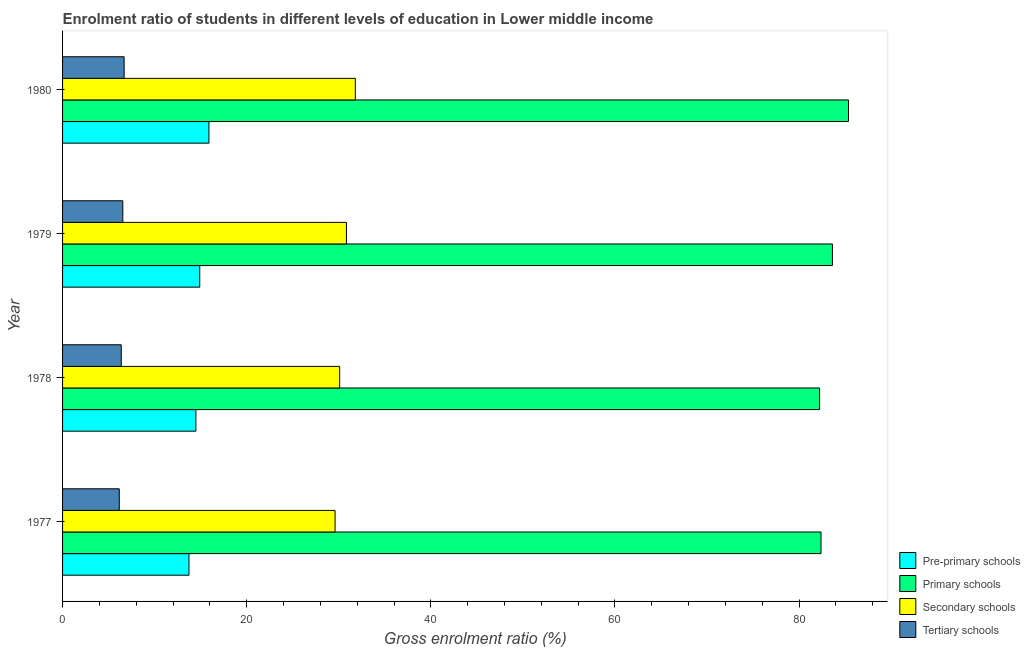How many different coloured bars are there?
Provide a short and direct response. 4. How many groups of bars are there?
Your answer should be compact. 4. Are the number of bars per tick equal to the number of legend labels?
Your answer should be compact. Yes. How many bars are there on the 4th tick from the top?
Provide a short and direct response. 4. How many bars are there on the 1st tick from the bottom?
Offer a terse response. 4. In how many cases, is the number of bars for a given year not equal to the number of legend labels?
Offer a terse response. 0. What is the gross enrolment ratio in primary schools in 1977?
Give a very brief answer. 82.38. Across all years, what is the maximum gross enrolment ratio in primary schools?
Give a very brief answer. 85.36. Across all years, what is the minimum gross enrolment ratio in secondary schools?
Offer a terse response. 29.6. In which year was the gross enrolment ratio in primary schools minimum?
Make the answer very short. 1978. What is the total gross enrolment ratio in pre-primary schools in the graph?
Your answer should be very brief. 59.01. What is the difference between the gross enrolment ratio in secondary schools in 1979 and that in 1980?
Offer a very short reply. -0.96. What is the difference between the gross enrolment ratio in secondary schools in 1977 and the gross enrolment ratio in pre-primary schools in 1978?
Offer a very short reply. 15.11. What is the average gross enrolment ratio in tertiary schools per year?
Keep it short and to the point. 6.44. In the year 1977, what is the difference between the gross enrolment ratio in pre-primary schools and gross enrolment ratio in primary schools?
Ensure brevity in your answer.  -68.65. In how many years, is the gross enrolment ratio in tertiary schools greater than 44 %?
Ensure brevity in your answer.  0. What is the ratio of the gross enrolment ratio in tertiary schools in 1977 to that in 1980?
Your answer should be very brief. 0.92. What is the difference between the highest and the second highest gross enrolment ratio in pre-primary schools?
Give a very brief answer. 1. What is the difference between the highest and the lowest gross enrolment ratio in secondary schools?
Provide a short and direct response. 2.2. In how many years, is the gross enrolment ratio in primary schools greater than the average gross enrolment ratio in primary schools taken over all years?
Offer a very short reply. 2. Is the sum of the gross enrolment ratio in secondary schools in 1979 and 1980 greater than the maximum gross enrolment ratio in primary schools across all years?
Give a very brief answer. No. What does the 3rd bar from the top in 1978 represents?
Your response must be concise. Primary schools. What does the 2nd bar from the bottom in 1978 represents?
Give a very brief answer. Primary schools. Is it the case that in every year, the sum of the gross enrolment ratio in pre-primary schools and gross enrolment ratio in primary schools is greater than the gross enrolment ratio in secondary schools?
Keep it short and to the point. Yes. Does the graph contain any zero values?
Your response must be concise. No. Where does the legend appear in the graph?
Make the answer very short. Bottom right. What is the title of the graph?
Your answer should be compact. Enrolment ratio of students in different levels of education in Lower middle income. What is the Gross enrolment ratio (%) of Pre-primary schools in 1977?
Make the answer very short. 13.73. What is the Gross enrolment ratio (%) in Primary schools in 1977?
Provide a short and direct response. 82.38. What is the Gross enrolment ratio (%) in Secondary schools in 1977?
Provide a short and direct response. 29.6. What is the Gross enrolment ratio (%) of Tertiary schools in 1977?
Ensure brevity in your answer.  6.16. What is the Gross enrolment ratio (%) of Pre-primary schools in 1978?
Keep it short and to the point. 14.48. What is the Gross enrolment ratio (%) in Primary schools in 1978?
Offer a terse response. 82.22. What is the Gross enrolment ratio (%) of Secondary schools in 1978?
Ensure brevity in your answer.  30.1. What is the Gross enrolment ratio (%) of Tertiary schools in 1978?
Provide a short and direct response. 6.37. What is the Gross enrolment ratio (%) of Pre-primary schools in 1979?
Your answer should be very brief. 14.9. What is the Gross enrolment ratio (%) in Primary schools in 1979?
Ensure brevity in your answer.  83.62. What is the Gross enrolment ratio (%) of Secondary schools in 1979?
Your answer should be very brief. 30.83. What is the Gross enrolment ratio (%) of Tertiary schools in 1979?
Keep it short and to the point. 6.54. What is the Gross enrolment ratio (%) of Pre-primary schools in 1980?
Provide a short and direct response. 15.9. What is the Gross enrolment ratio (%) of Primary schools in 1980?
Your answer should be compact. 85.36. What is the Gross enrolment ratio (%) of Secondary schools in 1980?
Keep it short and to the point. 31.8. What is the Gross enrolment ratio (%) of Tertiary schools in 1980?
Offer a terse response. 6.69. Across all years, what is the maximum Gross enrolment ratio (%) in Pre-primary schools?
Give a very brief answer. 15.9. Across all years, what is the maximum Gross enrolment ratio (%) of Primary schools?
Ensure brevity in your answer.  85.36. Across all years, what is the maximum Gross enrolment ratio (%) of Secondary schools?
Offer a very short reply. 31.8. Across all years, what is the maximum Gross enrolment ratio (%) in Tertiary schools?
Offer a terse response. 6.69. Across all years, what is the minimum Gross enrolment ratio (%) of Pre-primary schools?
Make the answer very short. 13.73. Across all years, what is the minimum Gross enrolment ratio (%) in Primary schools?
Give a very brief answer. 82.22. Across all years, what is the minimum Gross enrolment ratio (%) in Secondary schools?
Provide a short and direct response. 29.6. Across all years, what is the minimum Gross enrolment ratio (%) in Tertiary schools?
Offer a very short reply. 6.16. What is the total Gross enrolment ratio (%) of Pre-primary schools in the graph?
Provide a succinct answer. 59.01. What is the total Gross enrolment ratio (%) in Primary schools in the graph?
Ensure brevity in your answer.  333.58. What is the total Gross enrolment ratio (%) of Secondary schools in the graph?
Give a very brief answer. 122.33. What is the total Gross enrolment ratio (%) in Tertiary schools in the graph?
Provide a short and direct response. 25.76. What is the difference between the Gross enrolment ratio (%) of Pre-primary schools in 1977 and that in 1978?
Provide a short and direct response. -0.75. What is the difference between the Gross enrolment ratio (%) in Primary schools in 1977 and that in 1978?
Provide a succinct answer. 0.15. What is the difference between the Gross enrolment ratio (%) in Secondary schools in 1977 and that in 1978?
Provide a succinct answer. -0.5. What is the difference between the Gross enrolment ratio (%) of Tertiary schools in 1977 and that in 1978?
Offer a very short reply. -0.21. What is the difference between the Gross enrolment ratio (%) of Pre-primary schools in 1977 and that in 1979?
Make the answer very short. -1.17. What is the difference between the Gross enrolment ratio (%) in Primary schools in 1977 and that in 1979?
Offer a very short reply. -1.24. What is the difference between the Gross enrolment ratio (%) of Secondary schools in 1977 and that in 1979?
Provide a short and direct response. -1.24. What is the difference between the Gross enrolment ratio (%) of Tertiary schools in 1977 and that in 1979?
Offer a very short reply. -0.38. What is the difference between the Gross enrolment ratio (%) in Pre-primary schools in 1977 and that in 1980?
Keep it short and to the point. -2.17. What is the difference between the Gross enrolment ratio (%) of Primary schools in 1977 and that in 1980?
Keep it short and to the point. -2.99. What is the difference between the Gross enrolment ratio (%) in Secondary schools in 1977 and that in 1980?
Give a very brief answer. -2.2. What is the difference between the Gross enrolment ratio (%) in Tertiary schools in 1977 and that in 1980?
Ensure brevity in your answer.  -0.53. What is the difference between the Gross enrolment ratio (%) of Pre-primary schools in 1978 and that in 1979?
Give a very brief answer. -0.42. What is the difference between the Gross enrolment ratio (%) of Primary schools in 1978 and that in 1979?
Give a very brief answer. -1.39. What is the difference between the Gross enrolment ratio (%) of Secondary schools in 1978 and that in 1979?
Provide a succinct answer. -0.73. What is the difference between the Gross enrolment ratio (%) of Tertiary schools in 1978 and that in 1979?
Provide a succinct answer. -0.17. What is the difference between the Gross enrolment ratio (%) in Pre-primary schools in 1978 and that in 1980?
Ensure brevity in your answer.  -1.42. What is the difference between the Gross enrolment ratio (%) in Primary schools in 1978 and that in 1980?
Offer a very short reply. -3.14. What is the difference between the Gross enrolment ratio (%) in Secondary schools in 1978 and that in 1980?
Offer a very short reply. -1.7. What is the difference between the Gross enrolment ratio (%) in Tertiary schools in 1978 and that in 1980?
Your response must be concise. -0.31. What is the difference between the Gross enrolment ratio (%) of Pre-primary schools in 1979 and that in 1980?
Your answer should be compact. -1. What is the difference between the Gross enrolment ratio (%) of Primary schools in 1979 and that in 1980?
Provide a short and direct response. -1.75. What is the difference between the Gross enrolment ratio (%) in Secondary schools in 1979 and that in 1980?
Make the answer very short. -0.96. What is the difference between the Gross enrolment ratio (%) of Tertiary schools in 1979 and that in 1980?
Offer a very short reply. -0.14. What is the difference between the Gross enrolment ratio (%) of Pre-primary schools in 1977 and the Gross enrolment ratio (%) of Primary schools in 1978?
Your answer should be compact. -68.49. What is the difference between the Gross enrolment ratio (%) in Pre-primary schools in 1977 and the Gross enrolment ratio (%) in Secondary schools in 1978?
Make the answer very short. -16.37. What is the difference between the Gross enrolment ratio (%) of Pre-primary schools in 1977 and the Gross enrolment ratio (%) of Tertiary schools in 1978?
Make the answer very short. 7.35. What is the difference between the Gross enrolment ratio (%) of Primary schools in 1977 and the Gross enrolment ratio (%) of Secondary schools in 1978?
Make the answer very short. 52.28. What is the difference between the Gross enrolment ratio (%) in Primary schools in 1977 and the Gross enrolment ratio (%) in Tertiary schools in 1978?
Your response must be concise. 76. What is the difference between the Gross enrolment ratio (%) in Secondary schools in 1977 and the Gross enrolment ratio (%) in Tertiary schools in 1978?
Your answer should be very brief. 23.22. What is the difference between the Gross enrolment ratio (%) in Pre-primary schools in 1977 and the Gross enrolment ratio (%) in Primary schools in 1979?
Your response must be concise. -69.89. What is the difference between the Gross enrolment ratio (%) of Pre-primary schools in 1977 and the Gross enrolment ratio (%) of Secondary schools in 1979?
Provide a succinct answer. -17.1. What is the difference between the Gross enrolment ratio (%) in Pre-primary schools in 1977 and the Gross enrolment ratio (%) in Tertiary schools in 1979?
Offer a terse response. 7.19. What is the difference between the Gross enrolment ratio (%) in Primary schools in 1977 and the Gross enrolment ratio (%) in Secondary schools in 1979?
Offer a terse response. 51.54. What is the difference between the Gross enrolment ratio (%) of Primary schools in 1977 and the Gross enrolment ratio (%) of Tertiary schools in 1979?
Your answer should be compact. 75.83. What is the difference between the Gross enrolment ratio (%) in Secondary schools in 1977 and the Gross enrolment ratio (%) in Tertiary schools in 1979?
Offer a terse response. 23.05. What is the difference between the Gross enrolment ratio (%) in Pre-primary schools in 1977 and the Gross enrolment ratio (%) in Primary schools in 1980?
Provide a short and direct response. -71.64. What is the difference between the Gross enrolment ratio (%) of Pre-primary schools in 1977 and the Gross enrolment ratio (%) of Secondary schools in 1980?
Keep it short and to the point. -18.07. What is the difference between the Gross enrolment ratio (%) of Pre-primary schools in 1977 and the Gross enrolment ratio (%) of Tertiary schools in 1980?
Offer a very short reply. 7.04. What is the difference between the Gross enrolment ratio (%) in Primary schools in 1977 and the Gross enrolment ratio (%) in Secondary schools in 1980?
Your response must be concise. 50.58. What is the difference between the Gross enrolment ratio (%) of Primary schools in 1977 and the Gross enrolment ratio (%) of Tertiary schools in 1980?
Your answer should be very brief. 75.69. What is the difference between the Gross enrolment ratio (%) of Secondary schools in 1977 and the Gross enrolment ratio (%) of Tertiary schools in 1980?
Give a very brief answer. 22.91. What is the difference between the Gross enrolment ratio (%) of Pre-primary schools in 1978 and the Gross enrolment ratio (%) of Primary schools in 1979?
Your response must be concise. -69.13. What is the difference between the Gross enrolment ratio (%) of Pre-primary schools in 1978 and the Gross enrolment ratio (%) of Secondary schools in 1979?
Offer a very short reply. -16.35. What is the difference between the Gross enrolment ratio (%) of Pre-primary schools in 1978 and the Gross enrolment ratio (%) of Tertiary schools in 1979?
Offer a very short reply. 7.94. What is the difference between the Gross enrolment ratio (%) in Primary schools in 1978 and the Gross enrolment ratio (%) in Secondary schools in 1979?
Provide a succinct answer. 51.39. What is the difference between the Gross enrolment ratio (%) of Primary schools in 1978 and the Gross enrolment ratio (%) of Tertiary schools in 1979?
Make the answer very short. 75.68. What is the difference between the Gross enrolment ratio (%) of Secondary schools in 1978 and the Gross enrolment ratio (%) of Tertiary schools in 1979?
Keep it short and to the point. 23.56. What is the difference between the Gross enrolment ratio (%) of Pre-primary schools in 1978 and the Gross enrolment ratio (%) of Primary schools in 1980?
Offer a very short reply. -70.88. What is the difference between the Gross enrolment ratio (%) of Pre-primary schools in 1978 and the Gross enrolment ratio (%) of Secondary schools in 1980?
Your answer should be compact. -17.32. What is the difference between the Gross enrolment ratio (%) in Pre-primary schools in 1978 and the Gross enrolment ratio (%) in Tertiary schools in 1980?
Your response must be concise. 7.79. What is the difference between the Gross enrolment ratio (%) of Primary schools in 1978 and the Gross enrolment ratio (%) of Secondary schools in 1980?
Give a very brief answer. 50.43. What is the difference between the Gross enrolment ratio (%) in Primary schools in 1978 and the Gross enrolment ratio (%) in Tertiary schools in 1980?
Keep it short and to the point. 75.54. What is the difference between the Gross enrolment ratio (%) of Secondary schools in 1978 and the Gross enrolment ratio (%) of Tertiary schools in 1980?
Your answer should be compact. 23.41. What is the difference between the Gross enrolment ratio (%) of Pre-primary schools in 1979 and the Gross enrolment ratio (%) of Primary schools in 1980?
Your response must be concise. -70.46. What is the difference between the Gross enrolment ratio (%) in Pre-primary schools in 1979 and the Gross enrolment ratio (%) in Secondary schools in 1980?
Offer a terse response. -16.9. What is the difference between the Gross enrolment ratio (%) of Pre-primary schools in 1979 and the Gross enrolment ratio (%) of Tertiary schools in 1980?
Provide a succinct answer. 8.21. What is the difference between the Gross enrolment ratio (%) in Primary schools in 1979 and the Gross enrolment ratio (%) in Secondary schools in 1980?
Your response must be concise. 51.82. What is the difference between the Gross enrolment ratio (%) in Primary schools in 1979 and the Gross enrolment ratio (%) in Tertiary schools in 1980?
Provide a short and direct response. 76.93. What is the difference between the Gross enrolment ratio (%) in Secondary schools in 1979 and the Gross enrolment ratio (%) in Tertiary schools in 1980?
Give a very brief answer. 24.15. What is the average Gross enrolment ratio (%) in Pre-primary schools per year?
Your answer should be compact. 14.75. What is the average Gross enrolment ratio (%) in Primary schools per year?
Offer a terse response. 83.39. What is the average Gross enrolment ratio (%) in Secondary schools per year?
Give a very brief answer. 30.58. What is the average Gross enrolment ratio (%) in Tertiary schools per year?
Offer a very short reply. 6.44. In the year 1977, what is the difference between the Gross enrolment ratio (%) of Pre-primary schools and Gross enrolment ratio (%) of Primary schools?
Your response must be concise. -68.65. In the year 1977, what is the difference between the Gross enrolment ratio (%) in Pre-primary schools and Gross enrolment ratio (%) in Secondary schools?
Provide a succinct answer. -15.87. In the year 1977, what is the difference between the Gross enrolment ratio (%) of Pre-primary schools and Gross enrolment ratio (%) of Tertiary schools?
Offer a very short reply. 7.57. In the year 1977, what is the difference between the Gross enrolment ratio (%) in Primary schools and Gross enrolment ratio (%) in Secondary schools?
Ensure brevity in your answer.  52.78. In the year 1977, what is the difference between the Gross enrolment ratio (%) in Primary schools and Gross enrolment ratio (%) in Tertiary schools?
Ensure brevity in your answer.  76.22. In the year 1977, what is the difference between the Gross enrolment ratio (%) in Secondary schools and Gross enrolment ratio (%) in Tertiary schools?
Provide a succinct answer. 23.44. In the year 1978, what is the difference between the Gross enrolment ratio (%) of Pre-primary schools and Gross enrolment ratio (%) of Primary schools?
Make the answer very short. -67.74. In the year 1978, what is the difference between the Gross enrolment ratio (%) of Pre-primary schools and Gross enrolment ratio (%) of Secondary schools?
Keep it short and to the point. -15.62. In the year 1978, what is the difference between the Gross enrolment ratio (%) of Pre-primary schools and Gross enrolment ratio (%) of Tertiary schools?
Your answer should be very brief. 8.11. In the year 1978, what is the difference between the Gross enrolment ratio (%) of Primary schools and Gross enrolment ratio (%) of Secondary schools?
Provide a succinct answer. 52.12. In the year 1978, what is the difference between the Gross enrolment ratio (%) in Primary schools and Gross enrolment ratio (%) in Tertiary schools?
Give a very brief answer. 75.85. In the year 1978, what is the difference between the Gross enrolment ratio (%) in Secondary schools and Gross enrolment ratio (%) in Tertiary schools?
Offer a terse response. 23.73. In the year 1979, what is the difference between the Gross enrolment ratio (%) in Pre-primary schools and Gross enrolment ratio (%) in Primary schools?
Offer a terse response. -68.72. In the year 1979, what is the difference between the Gross enrolment ratio (%) of Pre-primary schools and Gross enrolment ratio (%) of Secondary schools?
Provide a succinct answer. -15.93. In the year 1979, what is the difference between the Gross enrolment ratio (%) of Pre-primary schools and Gross enrolment ratio (%) of Tertiary schools?
Provide a succinct answer. 8.36. In the year 1979, what is the difference between the Gross enrolment ratio (%) in Primary schools and Gross enrolment ratio (%) in Secondary schools?
Offer a terse response. 52.78. In the year 1979, what is the difference between the Gross enrolment ratio (%) in Primary schools and Gross enrolment ratio (%) in Tertiary schools?
Your response must be concise. 77.07. In the year 1979, what is the difference between the Gross enrolment ratio (%) of Secondary schools and Gross enrolment ratio (%) of Tertiary schools?
Give a very brief answer. 24.29. In the year 1980, what is the difference between the Gross enrolment ratio (%) in Pre-primary schools and Gross enrolment ratio (%) in Primary schools?
Offer a very short reply. -69.47. In the year 1980, what is the difference between the Gross enrolment ratio (%) in Pre-primary schools and Gross enrolment ratio (%) in Secondary schools?
Your answer should be very brief. -15.9. In the year 1980, what is the difference between the Gross enrolment ratio (%) in Pre-primary schools and Gross enrolment ratio (%) in Tertiary schools?
Your response must be concise. 9.21. In the year 1980, what is the difference between the Gross enrolment ratio (%) of Primary schools and Gross enrolment ratio (%) of Secondary schools?
Ensure brevity in your answer.  53.57. In the year 1980, what is the difference between the Gross enrolment ratio (%) of Primary schools and Gross enrolment ratio (%) of Tertiary schools?
Ensure brevity in your answer.  78.68. In the year 1980, what is the difference between the Gross enrolment ratio (%) of Secondary schools and Gross enrolment ratio (%) of Tertiary schools?
Your answer should be very brief. 25.11. What is the ratio of the Gross enrolment ratio (%) in Pre-primary schools in 1977 to that in 1978?
Provide a short and direct response. 0.95. What is the ratio of the Gross enrolment ratio (%) of Secondary schools in 1977 to that in 1978?
Keep it short and to the point. 0.98. What is the ratio of the Gross enrolment ratio (%) of Tertiary schools in 1977 to that in 1978?
Provide a short and direct response. 0.97. What is the ratio of the Gross enrolment ratio (%) of Pre-primary schools in 1977 to that in 1979?
Your response must be concise. 0.92. What is the ratio of the Gross enrolment ratio (%) in Primary schools in 1977 to that in 1979?
Give a very brief answer. 0.99. What is the ratio of the Gross enrolment ratio (%) of Secondary schools in 1977 to that in 1979?
Ensure brevity in your answer.  0.96. What is the ratio of the Gross enrolment ratio (%) in Tertiary schools in 1977 to that in 1979?
Provide a short and direct response. 0.94. What is the ratio of the Gross enrolment ratio (%) in Pre-primary schools in 1977 to that in 1980?
Provide a succinct answer. 0.86. What is the ratio of the Gross enrolment ratio (%) in Secondary schools in 1977 to that in 1980?
Your response must be concise. 0.93. What is the ratio of the Gross enrolment ratio (%) in Tertiary schools in 1977 to that in 1980?
Offer a terse response. 0.92. What is the ratio of the Gross enrolment ratio (%) in Pre-primary schools in 1978 to that in 1979?
Offer a terse response. 0.97. What is the ratio of the Gross enrolment ratio (%) in Primary schools in 1978 to that in 1979?
Offer a terse response. 0.98. What is the ratio of the Gross enrolment ratio (%) of Secondary schools in 1978 to that in 1979?
Make the answer very short. 0.98. What is the ratio of the Gross enrolment ratio (%) of Tertiary schools in 1978 to that in 1979?
Make the answer very short. 0.97. What is the ratio of the Gross enrolment ratio (%) of Pre-primary schools in 1978 to that in 1980?
Provide a short and direct response. 0.91. What is the ratio of the Gross enrolment ratio (%) of Primary schools in 1978 to that in 1980?
Your answer should be very brief. 0.96. What is the ratio of the Gross enrolment ratio (%) in Secondary schools in 1978 to that in 1980?
Make the answer very short. 0.95. What is the ratio of the Gross enrolment ratio (%) in Tertiary schools in 1978 to that in 1980?
Your answer should be very brief. 0.95. What is the ratio of the Gross enrolment ratio (%) in Pre-primary schools in 1979 to that in 1980?
Ensure brevity in your answer.  0.94. What is the ratio of the Gross enrolment ratio (%) in Primary schools in 1979 to that in 1980?
Make the answer very short. 0.98. What is the ratio of the Gross enrolment ratio (%) in Secondary schools in 1979 to that in 1980?
Offer a terse response. 0.97. What is the ratio of the Gross enrolment ratio (%) of Tertiary schools in 1979 to that in 1980?
Offer a terse response. 0.98. What is the difference between the highest and the second highest Gross enrolment ratio (%) in Primary schools?
Your response must be concise. 1.75. What is the difference between the highest and the second highest Gross enrolment ratio (%) in Secondary schools?
Your response must be concise. 0.96. What is the difference between the highest and the second highest Gross enrolment ratio (%) of Tertiary schools?
Your answer should be very brief. 0.14. What is the difference between the highest and the lowest Gross enrolment ratio (%) in Pre-primary schools?
Keep it short and to the point. 2.17. What is the difference between the highest and the lowest Gross enrolment ratio (%) of Primary schools?
Your response must be concise. 3.14. What is the difference between the highest and the lowest Gross enrolment ratio (%) of Secondary schools?
Your answer should be very brief. 2.2. What is the difference between the highest and the lowest Gross enrolment ratio (%) of Tertiary schools?
Ensure brevity in your answer.  0.53. 